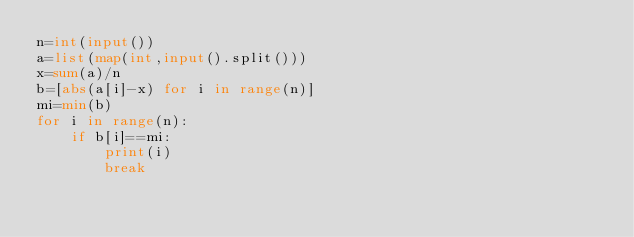Convert code to text. <code><loc_0><loc_0><loc_500><loc_500><_Python_>n=int(input())
a=list(map(int,input().split()))
x=sum(a)/n
b=[abs(a[i]-x) for i in range(n)]
mi=min(b)
for i in range(n):
    if b[i]==mi:
        print(i)
        break</code> 